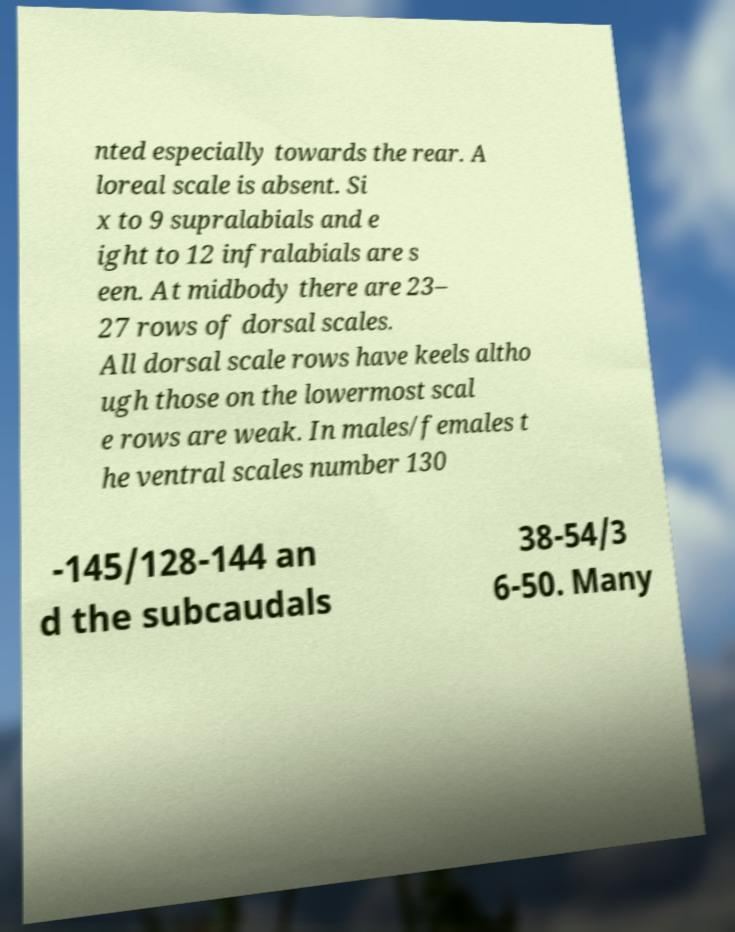Can you accurately transcribe the text from the provided image for me? nted especially towards the rear. A loreal scale is absent. Si x to 9 supralabials and e ight to 12 infralabials are s een. At midbody there are 23– 27 rows of dorsal scales. All dorsal scale rows have keels altho ugh those on the lowermost scal e rows are weak. In males/females t he ventral scales number 130 -145/128-144 an d the subcaudals 38-54/3 6-50. Many 